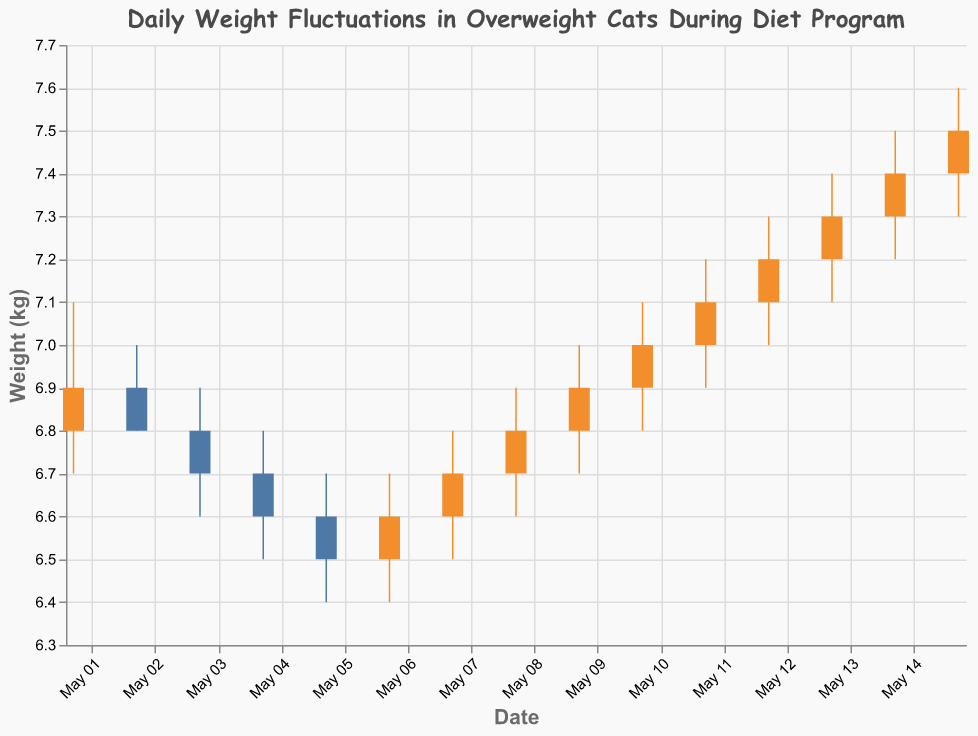What is the maximum weight recorded on May 4th? The "High" value for May 4th indicates the maximum weight recorded for that day. The chart shows that the "High" value on May 4th is 6.8 kg.
Answer: 6.8 kg On which date did the cats have the lowest recorded weight? The "Low" value across all dates needs to be examined. The lowest weight recorded is 6.4 kg, which can be seen on both May 5th and May 6th.
Answer: May 5, May 6 What is the weight trend from May 10 to May 12? Observing the "Close" values from May 10 to May 12, we see the weights are 7.0 kg on May 10, 7.1 kg on May 11, and 7.2 kg on May 12. This indicates an upward trend over these dates.
Answer: Upward trend Compare the "Open" and "Close" weights on May 1st. Did the weight increase or decrease? For May 1st, the "Open" weight is 6.8 kg and the "Close" weight is 6.9 kg. Since the "Close" weight is higher, we conclude there was an increase.
Answer: Increase Which date marks the highest increase in recorded weight within a single day? We need to find the date where the difference between the "Open" and "Close" weights is greatest and positive. The highest increase is from May 1st where the weight increased by 0.1 kg (from 6.8 kg to 6.9 kg).
Answer: May 1 What is the average "Close" weight from May 1 to May 15? Sum the "Close" values for all dates (6.9 + 6.8 + 6.7 + 6.6 + 6.5 + 6.6 + 6.7 + 6.8 + 6.9 + 7.0 + 7.1 + 7.2 + 7.3 + 7.4 + 7.5) and divide by the number of days (15). The sum is 101.0 kg, and the average is 101.0 / 15 = 6.73 kg.
Answer: 6.73 kg Did the weight on May 7th increase or decrease from the previous day? Compare the "Close" weight of May 7th (6.7 kg) with that of May 6th (6.6 kg). Since the "Close" weight on May 7th is higher, the weight increased.
Answer: Increased Identify the date where the "Open" and "Close" weights are the same. Check each date to see if the "Open" and "Close" weights are equal. May 2nd is the date where both are 6.8 kg.
Answer: May 2 What is the difference between the "High" weight of the first and last day in the chart? The "High" weight on May 1 is 7.1 kg and on May 15 is 7.6 kg. The difference is 7.6 - 7.1 = 0.5 kg.
Answer: 0.5 kg Was there any day where the weight remained the same throughout the day? Check if the "Open", "High", "Low", and "Close" values are the same for any date. No such day exists in the given data as all days have different values.
Answer: No 